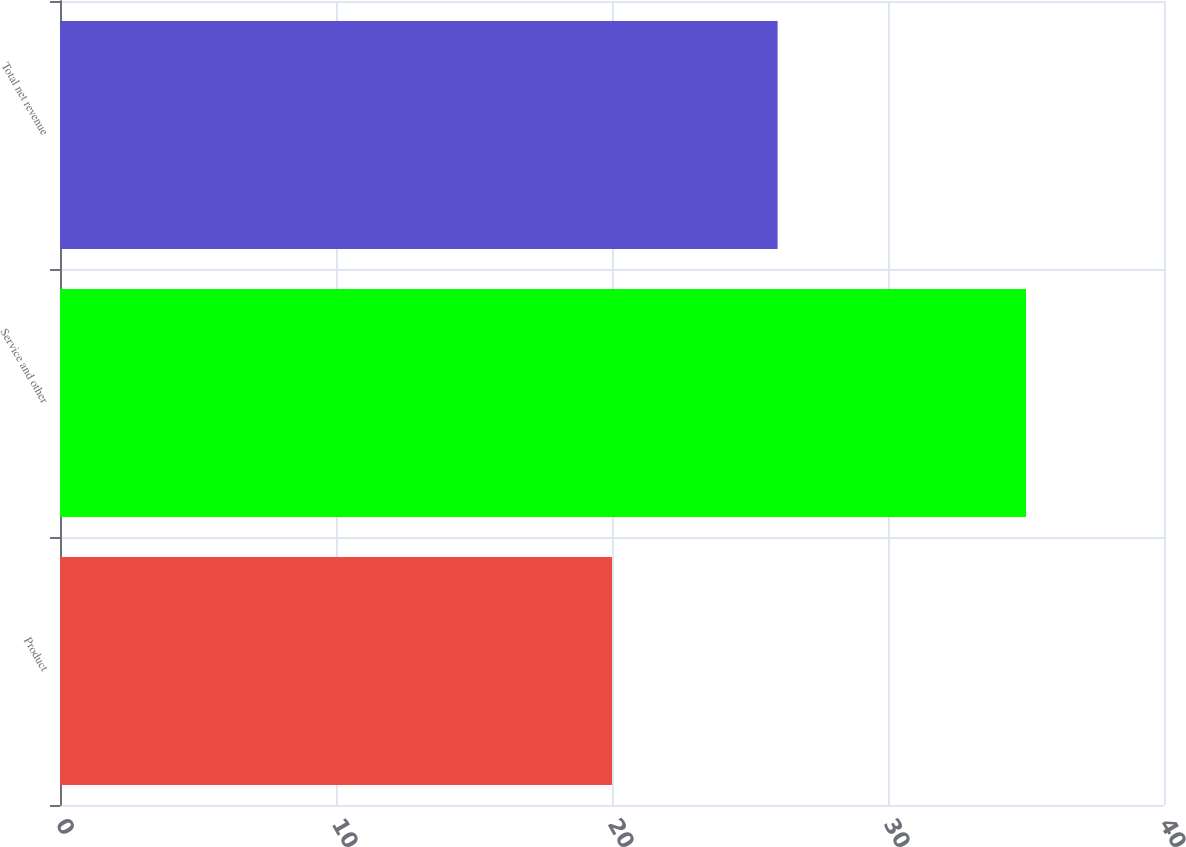<chart> <loc_0><loc_0><loc_500><loc_500><bar_chart><fcel>Product<fcel>Service and other<fcel>Total net revenue<nl><fcel>20<fcel>35<fcel>26<nl></chart> 